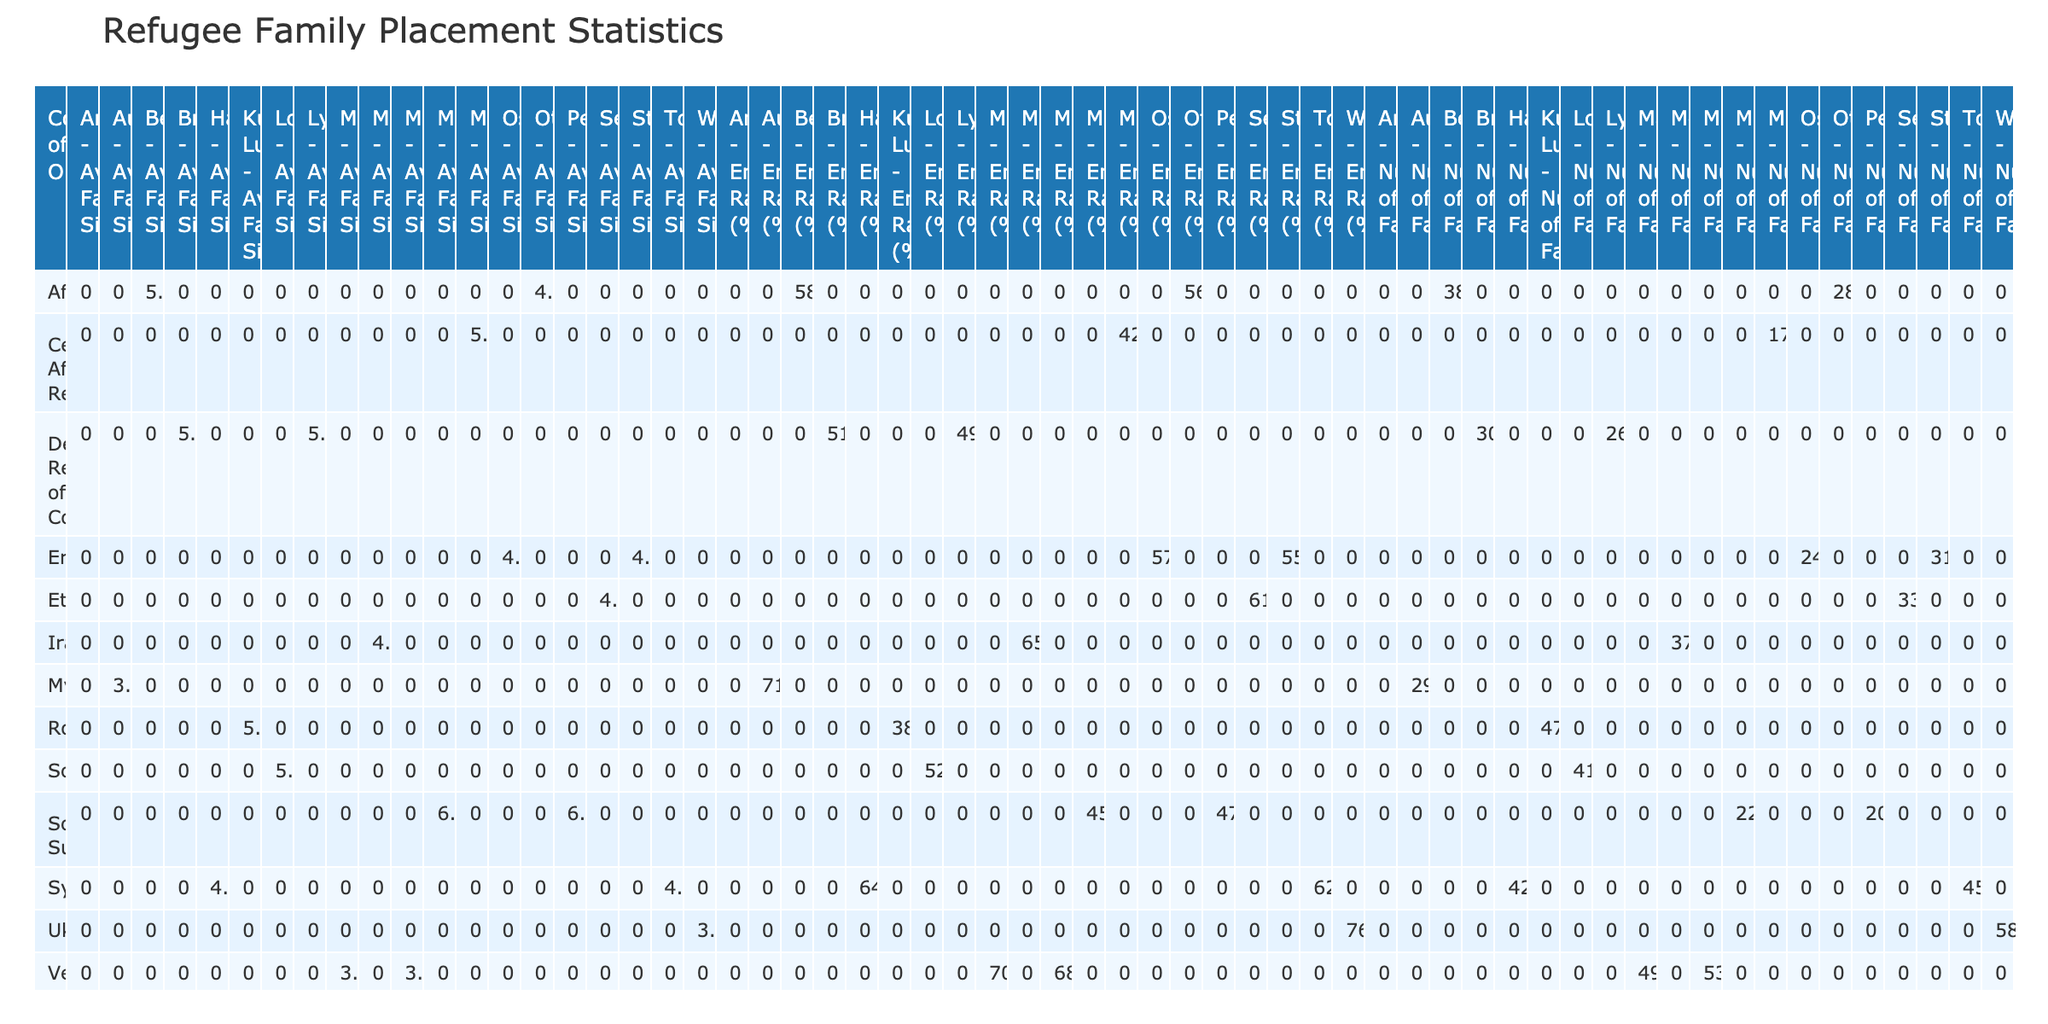What is the total number of families from Syria placed in Toronto? Referring to the table, under the 'Number of Families' column for the row labeled 'Syria' and the column 'Toronto,' the value is 45.
Answer: 45 What is the average family size of refugees from Afghanistan who settled in Berlin? In the table, for 'Afghanistan' in the 'Berlin' column, the 'Average Family Size' is 5.1.
Answer: 5.1 Are there any families from Eritrea in Stockholm that have an employment rate above 50%? The employment rate for Eritrean families in Stockholm, as per the table, is 55%, which is above 50%.
Answer: Yes What is the total number of families from Venezuela placed in both Miami and Madrid? The number of families from Venezuela in Miami is 53, and in Madrid, it is 49. Adding these together gives 53 + 49 = 102.
Answer: 102 Which destination city has the highest employment rate for families from Ukraine? The table shows that for 'Ukraine' in 'Warsaw,' the employment rate is 76%, which is the only listed for Ukraine, hence the highest.
Answer: 76% What is the average family size for families coming from South Sudan? In the table, the average family size for South Sudanese families in 'Minneapolis' is 6.3, while in 'Perth' it is 6.1. Calculating the average: (6.3 + 6.1) / 2 = 6.2.
Answer: 6.2 Is the number of families from Afghanistan greater in Berlin than in Ottawa? The table shows that Afghanistan has 38 families in Berlin and 28 families in Ottawa. Since 38 > 28, the answer is yes.
Answer: Yes What is the difference in average family size between families from Myanmar in Auckland and families from Yemen in Amsterdam? The average family size for Myanmar in Auckland is 3.8 and for Yemen in Amsterdam is 4.9. The difference is 4.9 - 3.8 = 1.1.
Answer: 1.1 Which country of origin has the highest total number of families and what is that number? By examining the data, we find that Ukraine has 58 families in Warsaw, Syria has a total of 45 (Toronto) + 42 (Hamburg) = 87, and Venezuela has a total of 53 (Miami) + 49 (Madrid) = 102. Thus, Venezuela has the highest total with 102 families.
Answer: 102 